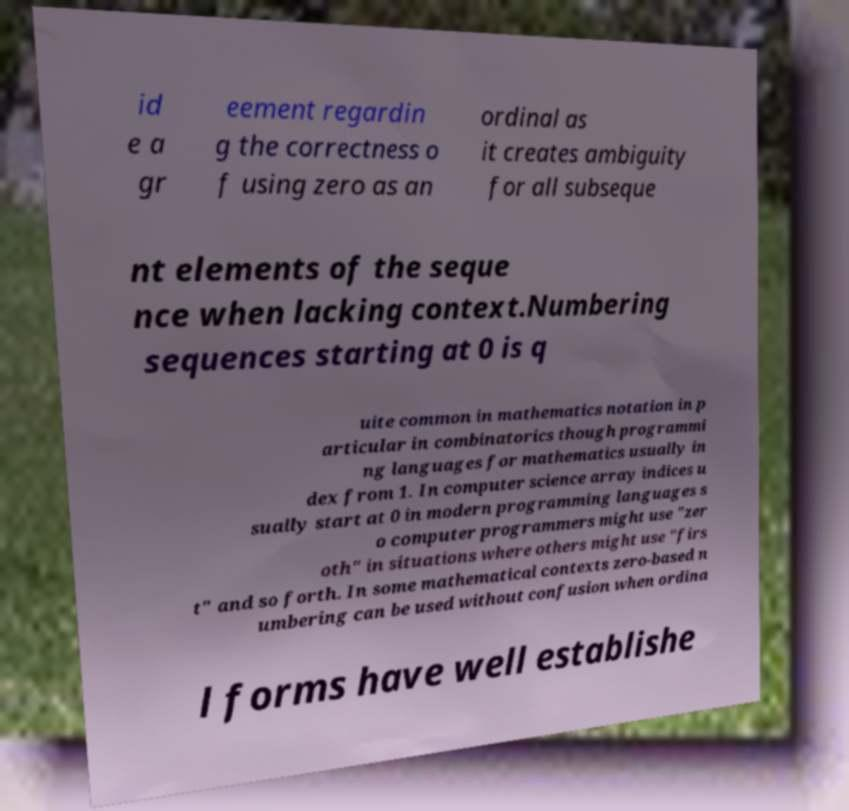I need the written content from this picture converted into text. Can you do that? id e a gr eement regardin g the correctness o f using zero as an ordinal as it creates ambiguity for all subseque nt elements of the seque nce when lacking context.Numbering sequences starting at 0 is q uite common in mathematics notation in p articular in combinatorics though programmi ng languages for mathematics usually in dex from 1. In computer science array indices u sually start at 0 in modern programming languages s o computer programmers might use "zer oth" in situations where others might use "firs t" and so forth. In some mathematical contexts zero-based n umbering can be used without confusion when ordina l forms have well establishe 